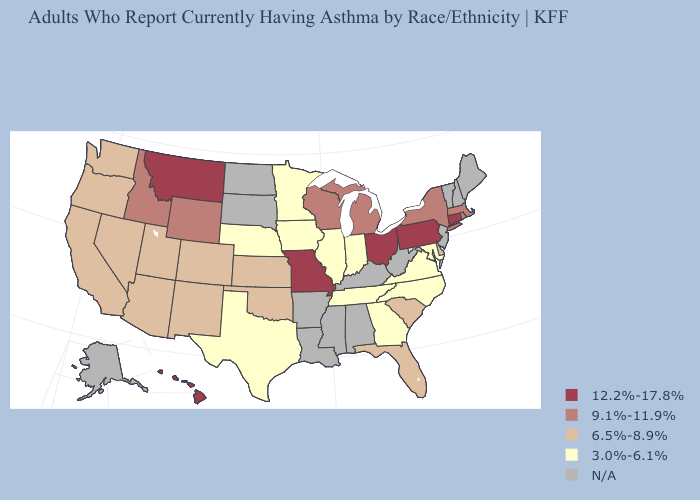Name the states that have a value in the range N/A?
Write a very short answer. Alabama, Alaska, Arkansas, Kentucky, Louisiana, Maine, Mississippi, New Hampshire, New Jersey, North Dakota, South Dakota, Vermont, West Virginia. What is the highest value in the USA?
Short answer required. 12.2%-17.8%. Does the first symbol in the legend represent the smallest category?
Write a very short answer. No. Name the states that have a value in the range 9.1%-11.9%?
Short answer required. Idaho, Massachusetts, Michigan, New York, Rhode Island, Wisconsin, Wyoming. Does Connecticut have the highest value in the Northeast?
Concise answer only. Yes. What is the value of Louisiana?
Give a very brief answer. N/A. Name the states that have a value in the range 3.0%-6.1%?
Answer briefly. Georgia, Illinois, Indiana, Iowa, Maryland, Minnesota, Nebraska, North Carolina, Tennessee, Texas, Virginia. Does Ohio have the highest value in the MidWest?
Keep it brief. Yes. Which states have the lowest value in the MidWest?
Be succinct. Illinois, Indiana, Iowa, Minnesota, Nebraska. What is the lowest value in states that border New Jersey?
Quick response, please. 6.5%-8.9%. Name the states that have a value in the range 3.0%-6.1%?
Answer briefly. Georgia, Illinois, Indiana, Iowa, Maryland, Minnesota, Nebraska, North Carolina, Tennessee, Texas, Virginia. What is the value of Kentucky?
Short answer required. N/A. Does Connecticut have the highest value in the Northeast?
Keep it brief. Yes. 